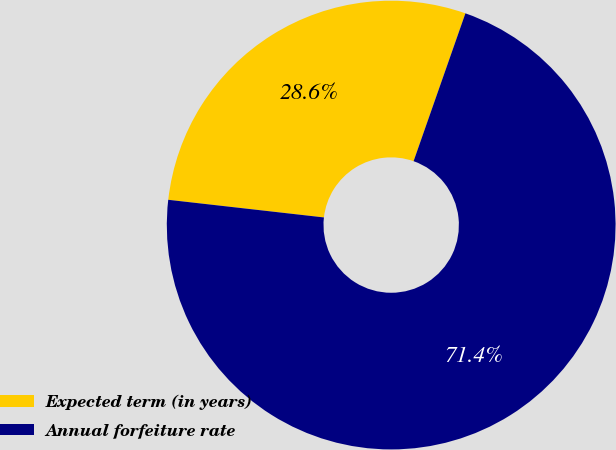<chart> <loc_0><loc_0><loc_500><loc_500><pie_chart><fcel>Expected term (in years)<fcel>Annual forfeiture rate<nl><fcel>28.57%<fcel>71.43%<nl></chart> 